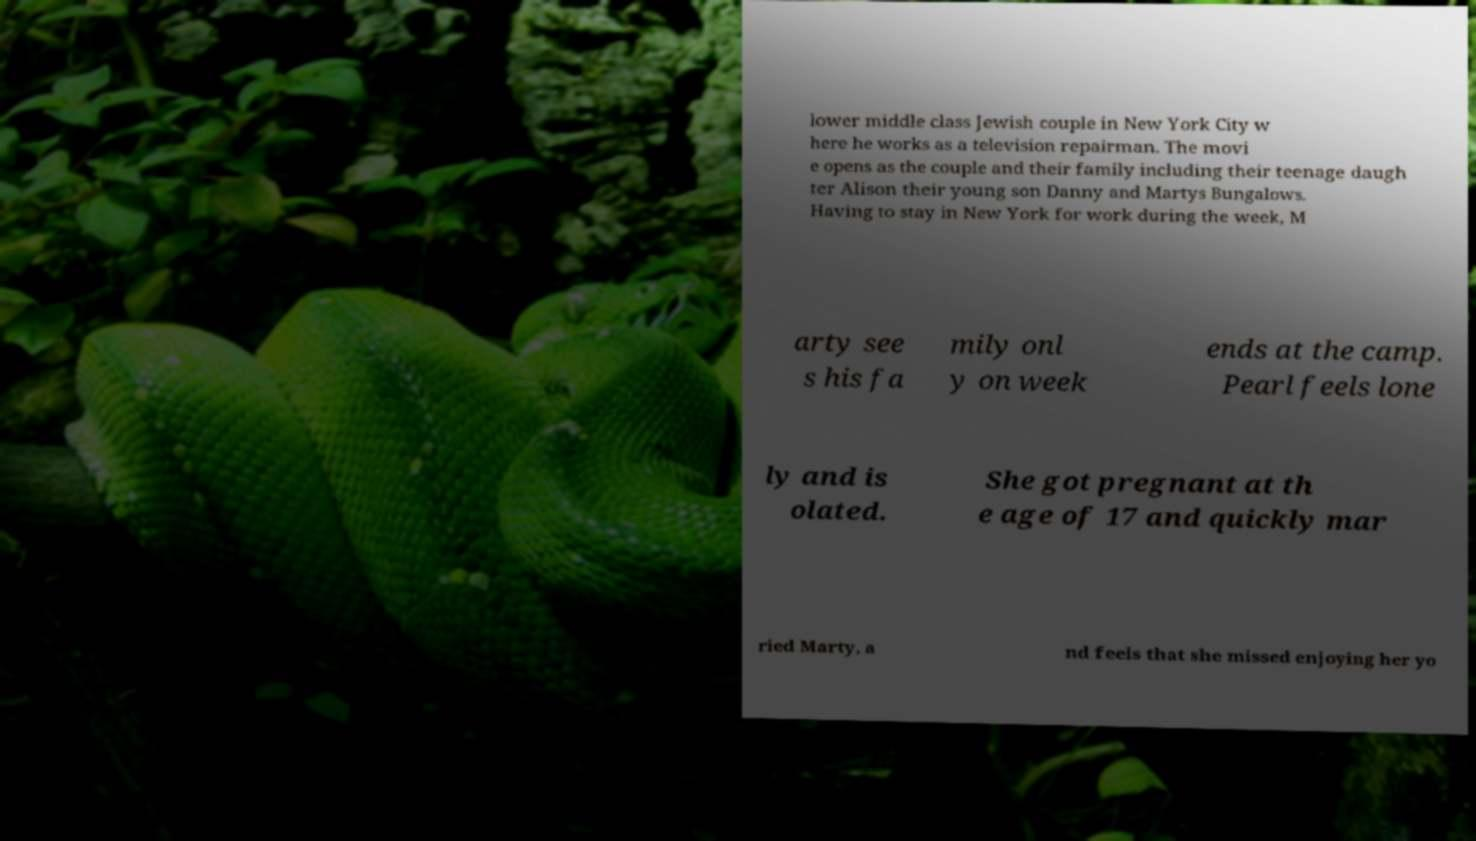There's text embedded in this image that I need extracted. Can you transcribe it verbatim? lower middle class Jewish couple in New York City w here he works as a television repairman. The movi e opens as the couple and their family including their teenage daugh ter Alison their young son Danny and Martys Bungalows. Having to stay in New York for work during the week, M arty see s his fa mily onl y on week ends at the camp. Pearl feels lone ly and is olated. She got pregnant at th e age of 17 and quickly mar ried Marty, a nd feels that she missed enjoying her yo 